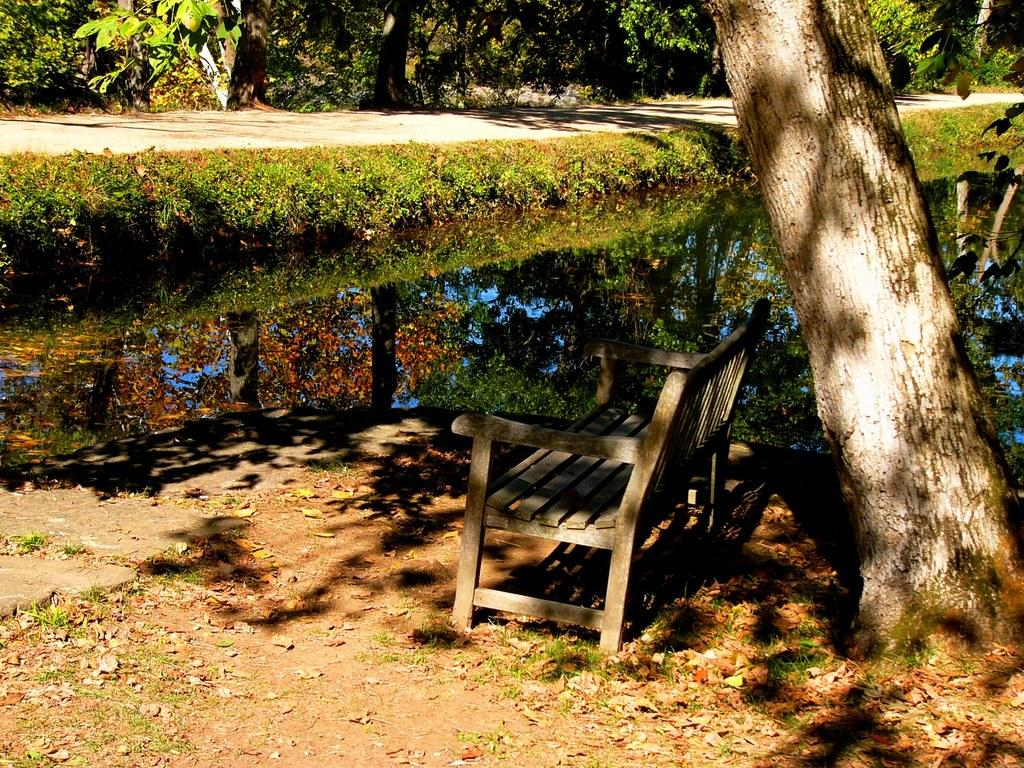What type of seating is present in the image? There is a bench in the image. What natural element can be seen in the image? Water is visible in the image. What type of vegetation is present in the image? There are plants and trees in the image. What theory is being discussed on the bench in the image? There is no discussion or theory present in the image; it only shows a bench, water, plants, and trees. What type of punishment is being administered to the trees in the image? There is no punishment being administered to the trees in the image; they are simply standing in the background. 